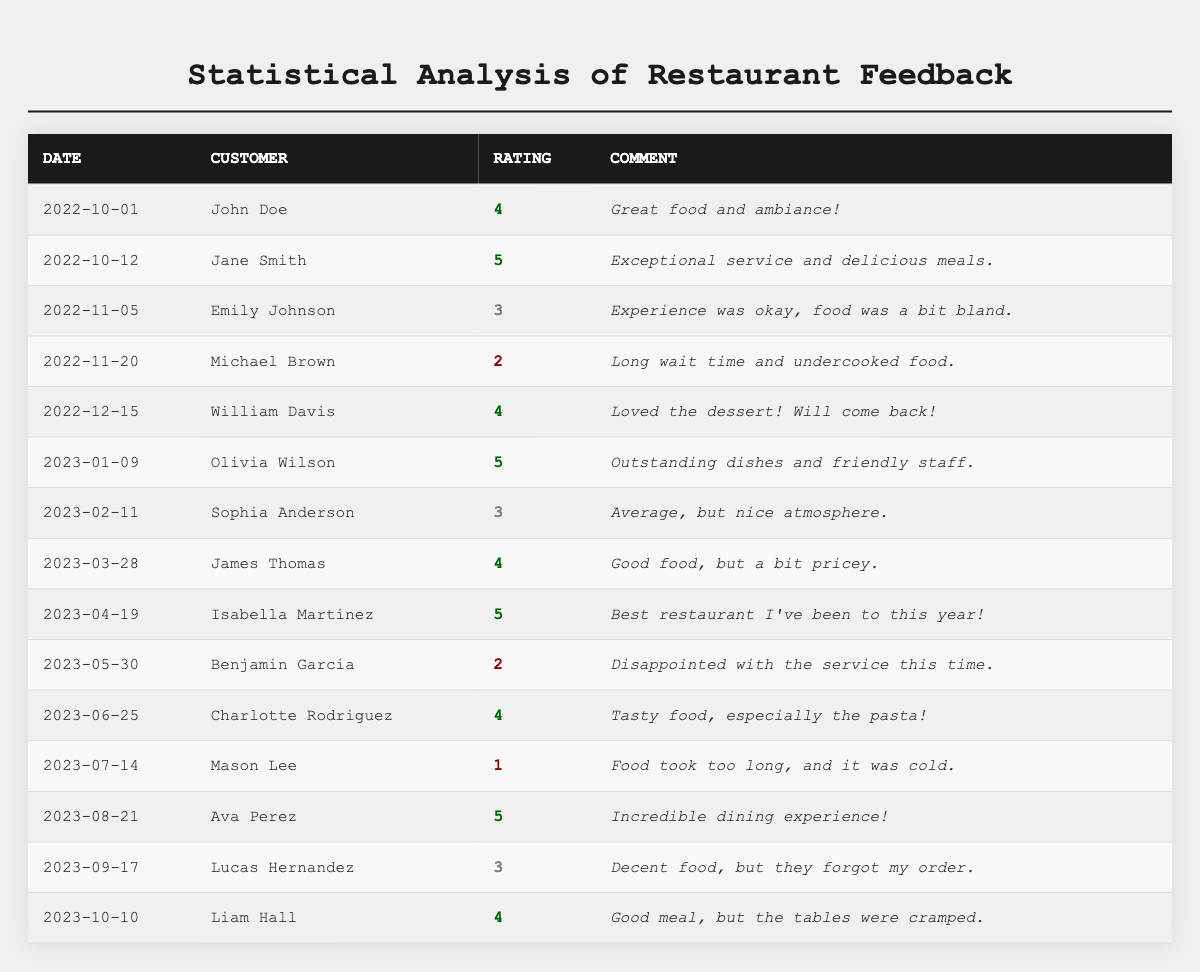What is the highest rating received by a customer? The maximum rating noted in the table is 5, which was received by Jane Smith, Olivia Wilson, Isabella Martinez, and Ava Perez.
Answer: 5 How many ratings were below 3? The table shows two ratings that are below 3: a 2 from Michael Brown and a 1 from Mason Lee.
Answer: 2 What was the average rating for all feedbacks? The ratings are: 4, 5, 3, 2, 4, 5, 3, 4, 5, 2, 4, 1, 5, 3, 4. Summing these gives 57, and there are 15 ratings, so the average is 57/15 = 3.8.
Answer: 3.8 Which customer left a comment about long wait time? Michael Brown mentioned a long wait time in his feedback on November 20.
Answer: Michael Brown Did any customer rate below 3 without providing a positive comment? Yes, Mason Lee rated 1 and his comment was negative regarding the food being cold and taking too long.
Answer: Yes What percentage of the provided ratings were 4 or above? The qualifying ratings that are 4 or higher are 4 (5 times) out of 15 total ratings; therefore, the percentage is (5/15)*100 = 33.33%.
Answer: 33.33% Which comment was the most favorable regarding the dining experience? Ava Perez states "Incredible dining experience!" which is a highly positive remark.
Answer: Incredible dining experience How does the average rating of the second half of the year compare to the first half? The first half ratings (Jan to Jun) are: 5, 3, 4, 5, 2, 4 totaling 23/6 = 3.83. The second half (Jul to Oct) is: 1, 5, 3, 4 totaling 13/4 = 3.25; comparing gives 3.83 vs 3.25, indicating the first half was better.
Answer: The first half was better How many customers mentioned food quality positively? The comments mentioning food quality positively include: "Great food and ambiance!" (John Doe), "Outstanding dishes" (Olivia Wilson), "Good food" (James Thomas), "Tasty food" (Charlotte Rodriguez), and "Incredible dining experience!" (Ava Perez). This sums to 5 comments.
Answer: 5 Was there any consistent negative feedback across multiple reviews? Yes, repeated negative feedback included mentions of long wait times and cold food, specifically from Michael Brown and Mason Lee.
Answer: Yes What was the trend in customer ratings from October 2022 to October 2023? The ratings showed an increase in positive experiences in early months, with a peak of 5 ratings, followed by a decline towards the middle of the year with lower ratings in July and May, before stabilizing again near the end.
Answer: Increase followed by decline and stabilization 